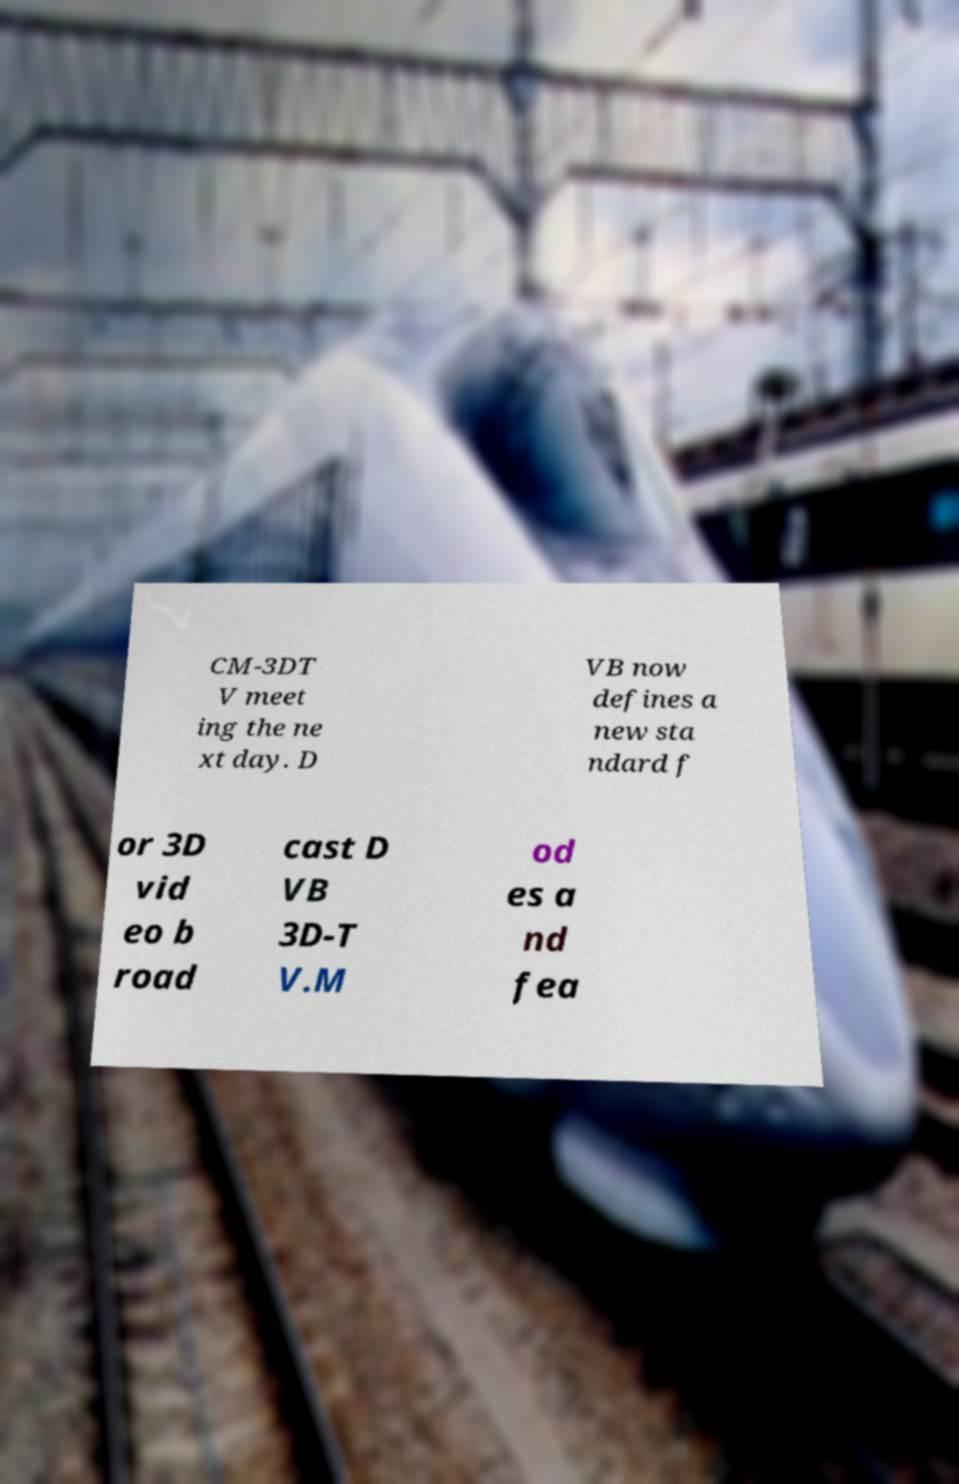For documentation purposes, I need the text within this image transcribed. Could you provide that? CM-3DT V meet ing the ne xt day. D VB now defines a new sta ndard f or 3D vid eo b road cast D VB 3D-T V.M od es a nd fea 